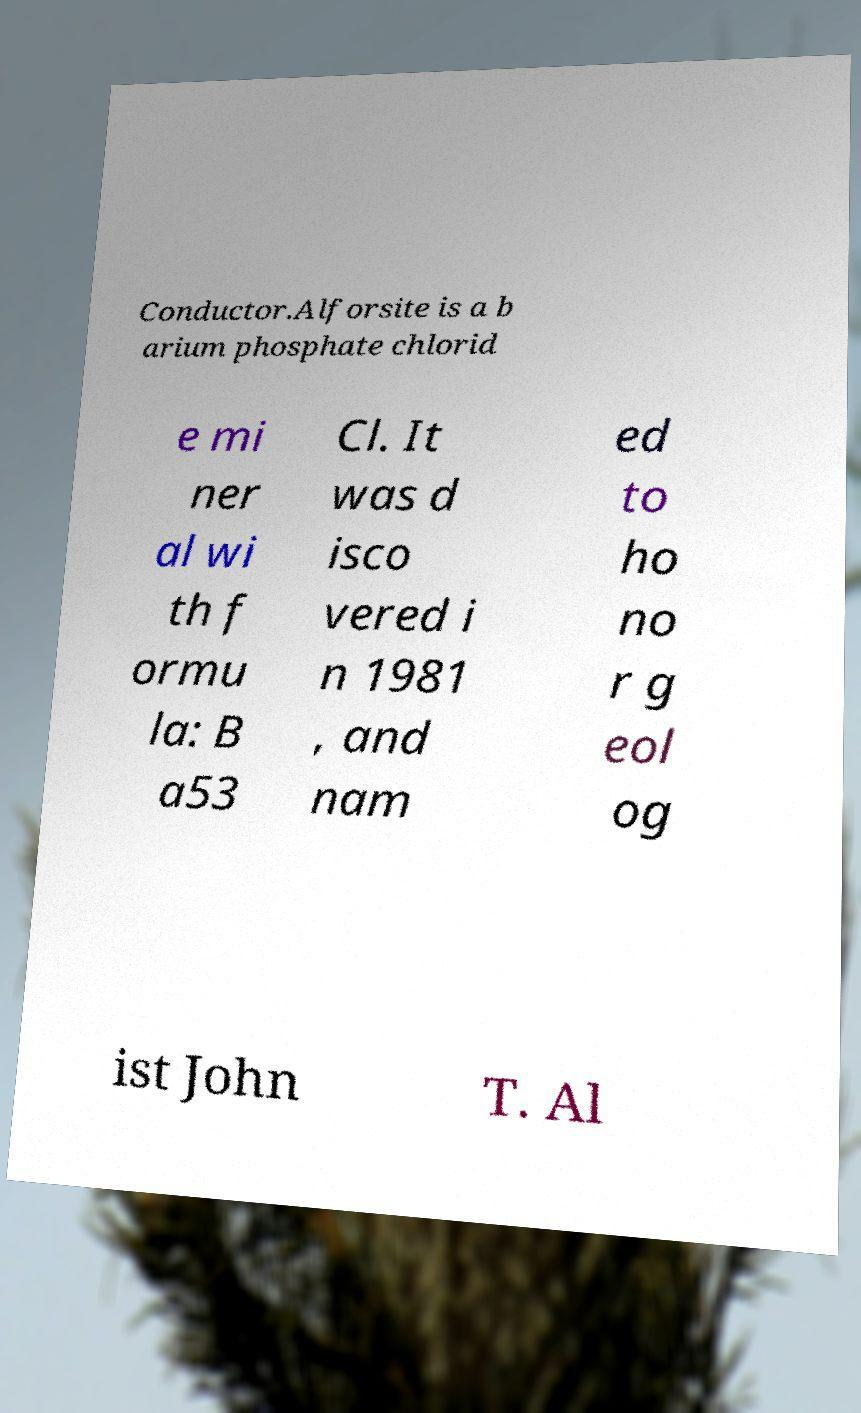Please read and relay the text visible in this image. What does it say? Conductor.Alforsite is a b arium phosphate chlorid e mi ner al wi th f ormu la: B a53 Cl. It was d isco vered i n 1981 , and nam ed to ho no r g eol og ist John T. Al 